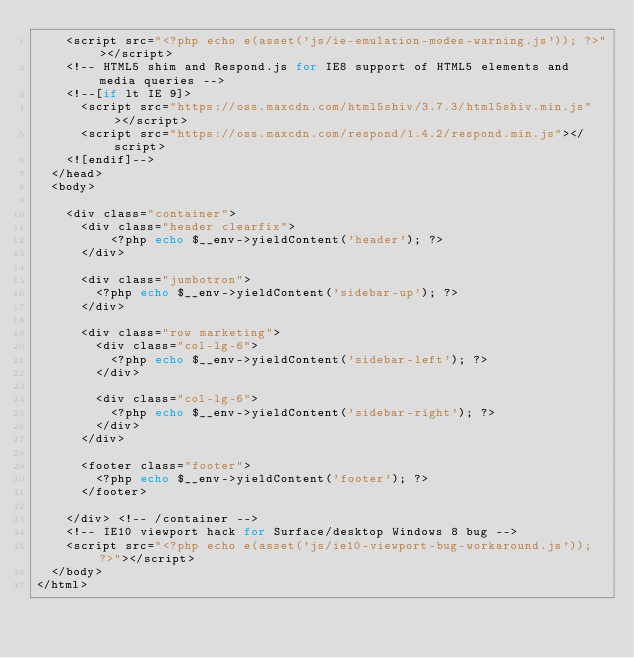Convert code to text. <code><loc_0><loc_0><loc_500><loc_500><_PHP_>    <script src="<?php echo e(asset('js/ie-emulation-modes-warning.js')); ?>"></script>
    <!-- HTML5 shim and Respond.js for IE8 support of HTML5 elements and media queries -->
    <!--[if lt IE 9]>
      <script src="https://oss.maxcdn.com/html5shiv/3.7.3/html5shiv.min.js"></script>
      <script src="https://oss.maxcdn.com/respond/1.4.2/respond.min.js"></script>
    <![endif]-->
  </head>
  <body>

    <div class="container">
      <div class="header clearfix">
          <?php echo $__env->yieldContent('header'); ?>
      </div>

      <div class="jumbotron">
        <?php echo $__env->yieldContent('sidebar-up'); ?>
      </div>

      <div class="row marketing">
        <div class="col-lg-6">
          <?php echo $__env->yieldContent('sidebar-left'); ?>
        </div>

        <div class="col-lg-6">
          <?php echo $__env->yieldContent('sidebar-right'); ?>
        </div>
      </div>

      <footer class="footer">
        <?php echo $__env->yieldContent('footer'); ?>
      </footer>

    </div> <!-- /container -->
    <!-- IE10 viewport hack for Surface/desktop Windows 8 bug -->
    <script src="<?php echo e(asset('js/ie10-viewport-bug-workaround.js')); ?>"></script>
  </body>
</html></code> 